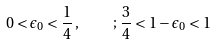<formula> <loc_0><loc_0><loc_500><loc_500>0 < \epsilon _ { 0 } < \frac { 1 } { 4 } \, , \quad ; \, \frac { 3 } { 4 } < 1 - \epsilon _ { 0 } < 1</formula> 